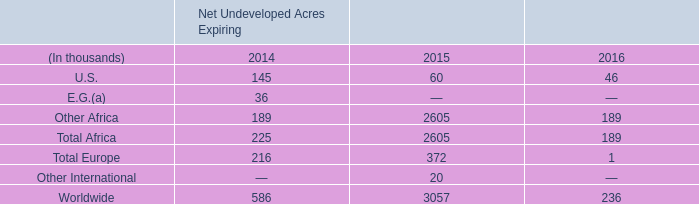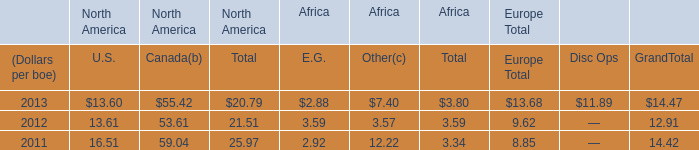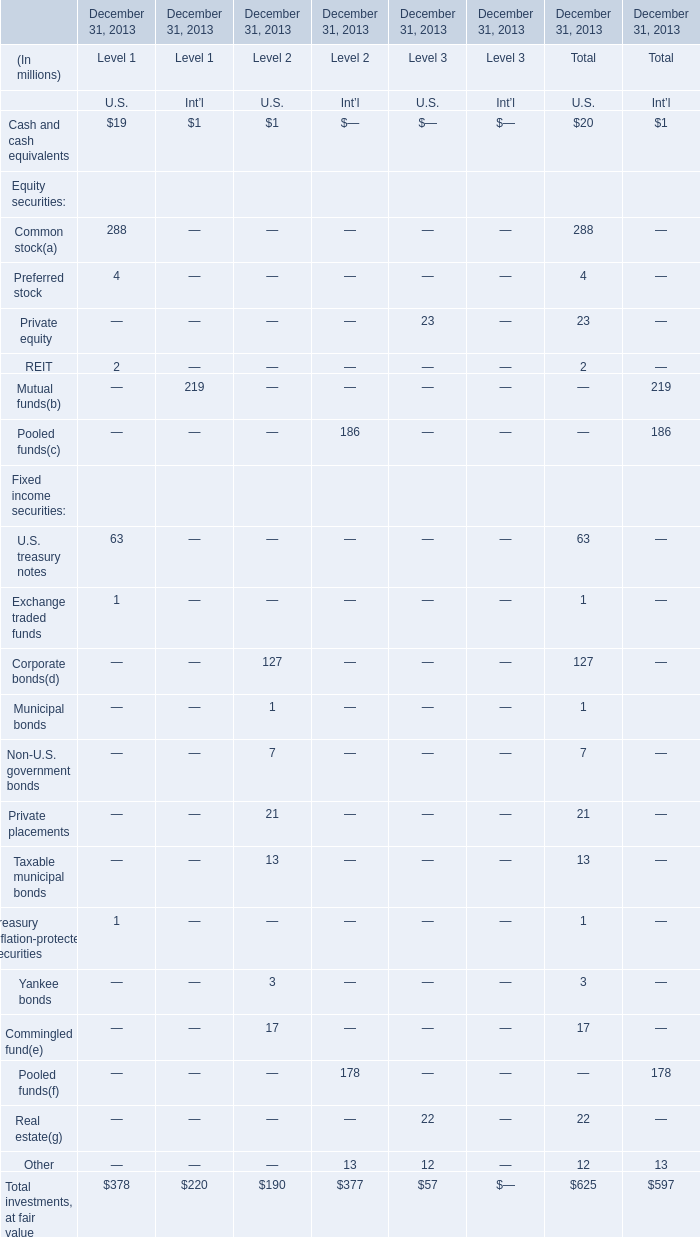What do all elements sum up for U.S. of Level 1 , excluding Exchange traded funds and Treasury inflation-protected securities? (in million) 
Computations: ((((19 + 288) + 4) + 2) + 63)
Answer: 376.0. 